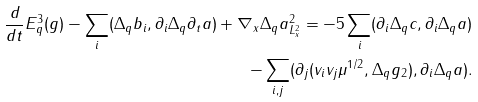<formula> <loc_0><loc_0><loc_500><loc_500>\frac { d } { d t } E ^ { 3 } _ { q } ( g ) - \sum _ { i } ( \Delta _ { q } b _ { i } , \partial _ { i } \Delta _ { q } \partial _ { t } a ) + \| \nabla _ { x } \Delta _ { q } a \| ^ { 2 } _ { L ^ { 2 } _ { x } } = - 5 \sum _ { i } ( \partial _ { i } \Delta _ { q } c , \partial _ { i } \Delta _ { q } a ) \\ - \sum _ { i , j } ( \partial _ { j } ( v _ { i } v _ { j } \mu ^ { 1 / 2 } , \Delta _ { q } g _ { 2 } ) , \partial _ { i } \Delta _ { q } a ) .</formula> 